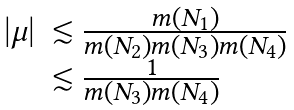Convert formula to latex. <formula><loc_0><loc_0><loc_500><loc_500>\begin{array} { l l } \left | \mu \right | & \lesssim \frac { m ( N _ { 1 } ) } { m ( N _ { 2 } ) m ( N _ { 3 } ) m ( N _ { 4 } ) } \\ & \lesssim \frac { 1 } { m ( N _ { 3 } ) m ( N _ { 4 } ) } \end{array}</formula> 